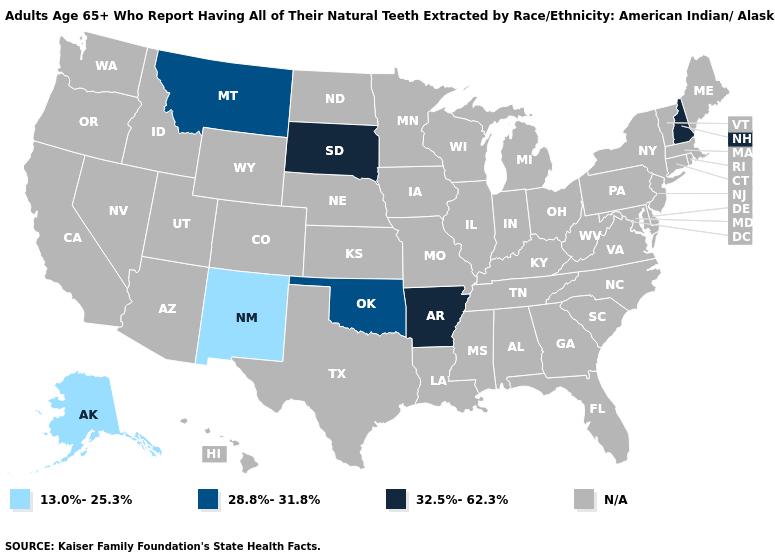What is the value of Louisiana?
Short answer required. N/A. What is the lowest value in the South?
Concise answer only. 28.8%-31.8%. Which states have the highest value in the USA?
Answer briefly. Arkansas, New Hampshire, South Dakota. What is the value of Idaho?
Write a very short answer. N/A. Name the states that have a value in the range N/A?
Give a very brief answer. Alabama, Arizona, California, Colorado, Connecticut, Delaware, Florida, Georgia, Hawaii, Idaho, Illinois, Indiana, Iowa, Kansas, Kentucky, Louisiana, Maine, Maryland, Massachusetts, Michigan, Minnesota, Mississippi, Missouri, Nebraska, Nevada, New Jersey, New York, North Carolina, North Dakota, Ohio, Oregon, Pennsylvania, Rhode Island, South Carolina, Tennessee, Texas, Utah, Vermont, Virginia, Washington, West Virginia, Wisconsin, Wyoming. Does New Mexico have the highest value in the USA?
Give a very brief answer. No. Which states have the lowest value in the USA?
Give a very brief answer. Alaska, New Mexico. Name the states that have a value in the range N/A?
Answer briefly. Alabama, Arizona, California, Colorado, Connecticut, Delaware, Florida, Georgia, Hawaii, Idaho, Illinois, Indiana, Iowa, Kansas, Kentucky, Louisiana, Maine, Maryland, Massachusetts, Michigan, Minnesota, Mississippi, Missouri, Nebraska, Nevada, New Jersey, New York, North Carolina, North Dakota, Ohio, Oregon, Pennsylvania, Rhode Island, South Carolina, Tennessee, Texas, Utah, Vermont, Virginia, Washington, West Virginia, Wisconsin, Wyoming. What is the value of New Jersey?
Short answer required. N/A. Does the map have missing data?
Keep it brief. Yes. Which states hav the highest value in the West?
Give a very brief answer. Montana. Name the states that have a value in the range 13.0%-25.3%?
Concise answer only. Alaska, New Mexico. How many symbols are there in the legend?
Be succinct. 4. 